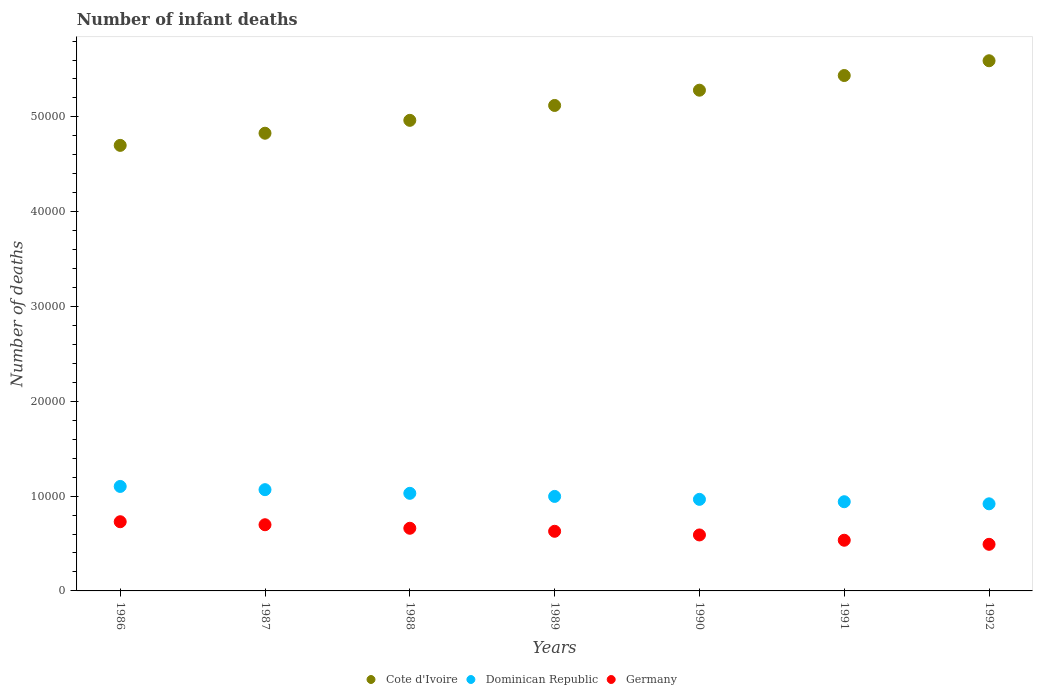Is the number of dotlines equal to the number of legend labels?
Your answer should be compact. Yes. What is the number of infant deaths in Germany in 1992?
Keep it short and to the point. 4916. Across all years, what is the maximum number of infant deaths in Germany?
Give a very brief answer. 7298. Across all years, what is the minimum number of infant deaths in Dominican Republic?
Your answer should be very brief. 9187. In which year was the number of infant deaths in Dominican Republic minimum?
Your answer should be compact. 1992. What is the total number of infant deaths in Germany in the graph?
Offer a terse response. 4.33e+04. What is the difference between the number of infant deaths in Germany in 1986 and that in 1990?
Your answer should be very brief. 1394. What is the difference between the number of infant deaths in Cote d'Ivoire in 1989 and the number of infant deaths in Dominican Republic in 1987?
Ensure brevity in your answer.  4.05e+04. What is the average number of infant deaths in Dominican Republic per year?
Make the answer very short. 1.00e+04. In the year 1986, what is the difference between the number of infant deaths in Germany and number of infant deaths in Cote d'Ivoire?
Your answer should be very brief. -3.97e+04. What is the ratio of the number of infant deaths in Germany in 1991 to that in 1992?
Ensure brevity in your answer.  1.09. Is the difference between the number of infant deaths in Germany in 1986 and 1992 greater than the difference between the number of infant deaths in Cote d'Ivoire in 1986 and 1992?
Your answer should be compact. Yes. What is the difference between the highest and the second highest number of infant deaths in Dominican Republic?
Ensure brevity in your answer.  341. What is the difference between the highest and the lowest number of infant deaths in Cote d'Ivoire?
Your response must be concise. 8926. Is the sum of the number of infant deaths in Cote d'Ivoire in 1986 and 1988 greater than the maximum number of infant deaths in Germany across all years?
Offer a very short reply. Yes. Is the number of infant deaths in Cote d'Ivoire strictly less than the number of infant deaths in Dominican Republic over the years?
Your response must be concise. No. How many years are there in the graph?
Keep it short and to the point. 7. Does the graph contain grids?
Make the answer very short. No. What is the title of the graph?
Your answer should be compact. Number of infant deaths. Does "Latin America(all income levels)" appear as one of the legend labels in the graph?
Your answer should be compact. No. What is the label or title of the X-axis?
Keep it short and to the point. Years. What is the label or title of the Y-axis?
Provide a short and direct response. Number of deaths. What is the Number of deaths of Cote d'Ivoire in 1986?
Offer a terse response. 4.70e+04. What is the Number of deaths in Dominican Republic in 1986?
Provide a short and direct response. 1.10e+04. What is the Number of deaths of Germany in 1986?
Make the answer very short. 7298. What is the Number of deaths of Cote d'Ivoire in 1987?
Offer a terse response. 4.83e+04. What is the Number of deaths of Dominican Republic in 1987?
Your response must be concise. 1.07e+04. What is the Number of deaths in Germany in 1987?
Your answer should be very brief. 6981. What is the Number of deaths in Cote d'Ivoire in 1988?
Ensure brevity in your answer.  4.96e+04. What is the Number of deaths of Dominican Republic in 1988?
Provide a succinct answer. 1.03e+04. What is the Number of deaths of Germany in 1988?
Your answer should be very brief. 6609. What is the Number of deaths of Cote d'Ivoire in 1989?
Provide a succinct answer. 5.12e+04. What is the Number of deaths in Dominican Republic in 1989?
Ensure brevity in your answer.  9968. What is the Number of deaths in Germany in 1989?
Provide a succinct answer. 6290. What is the Number of deaths of Cote d'Ivoire in 1990?
Keep it short and to the point. 5.28e+04. What is the Number of deaths of Dominican Republic in 1990?
Keep it short and to the point. 9658. What is the Number of deaths of Germany in 1990?
Give a very brief answer. 5904. What is the Number of deaths in Cote d'Ivoire in 1991?
Your answer should be compact. 5.44e+04. What is the Number of deaths in Dominican Republic in 1991?
Your answer should be compact. 9408. What is the Number of deaths of Germany in 1991?
Offer a terse response. 5346. What is the Number of deaths in Cote d'Ivoire in 1992?
Offer a terse response. 5.59e+04. What is the Number of deaths in Dominican Republic in 1992?
Your answer should be compact. 9187. What is the Number of deaths in Germany in 1992?
Ensure brevity in your answer.  4916. Across all years, what is the maximum Number of deaths in Cote d'Ivoire?
Keep it short and to the point. 5.59e+04. Across all years, what is the maximum Number of deaths of Dominican Republic?
Offer a terse response. 1.10e+04. Across all years, what is the maximum Number of deaths in Germany?
Your answer should be compact. 7298. Across all years, what is the minimum Number of deaths of Cote d'Ivoire?
Keep it short and to the point. 4.70e+04. Across all years, what is the minimum Number of deaths of Dominican Republic?
Keep it short and to the point. 9187. Across all years, what is the minimum Number of deaths of Germany?
Offer a very short reply. 4916. What is the total Number of deaths in Cote d'Ivoire in the graph?
Give a very brief answer. 3.59e+05. What is the total Number of deaths of Dominican Republic in the graph?
Your answer should be compact. 7.02e+04. What is the total Number of deaths in Germany in the graph?
Give a very brief answer. 4.33e+04. What is the difference between the Number of deaths in Cote d'Ivoire in 1986 and that in 1987?
Give a very brief answer. -1282. What is the difference between the Number of deaths in Dominican Republic in 1986 and that in 1987?
Offer a very short reply. 341. What is the difference between the Number of deaths in Germany in 1986 and that in 1987?
Provide a succinct answer. 317. What is the difference between the Number of deaths of Cote d'Ivoire in 1986 and that in 1988?
Offer a very short reply. -2641. What is the difference between the Number of deaths in Dominican Republic in 1986 and that in 1988?
Make the answer very short. 727. What is the difference between the Number of deaths of Germany in 1986 and that in 1988?
Your answer should be compact. 689. What is the difference between the Number of deaths of Cote d'Ivoire in 1986 and that in 1989?
Offer a very short reply. -4211. What is the difference between the Number of deaths of Dominican Republic in 1986 and that in 1989?
Make the answer very short. 1053. What is the difference between the Number of deaths in Germany in 1986 and that in 1989?
Keep it short and to the point. 1008. What is the difference between the Number of deaths in Cote d'Ivoire in 1986 and that in 1990?
Your response must be concise. -5820. What is the difference between the Number of deaths in Dominican Republic in 1986 and that in 1990?
Make the answer very short. 1363. What is the difference between the Number of deaths of Germany in 1986 and that in 1990?
Offer a very short reply. 1394. What is the difference between the Number of deaths of Cote d'Ivoire in 1986 and that in 1991?
Your answer should be very brief. -7368. What is the difference between the Number of deaths of Dominican Republic in 1986 and that in 1991?
Provide a short and direct response. 1613. What is the difference between the Number of deaths of Germany in 1986 and that in 1991?
Keep it short and to the point. 1952. What is the difference between the Number of deaths of Cote d'Ivoire in 1986 and that in 1992?
Provide a succinct answer. -8926. What is the difference between the Number of deaths of Dominican Republic in 1986 and that in 1992?
Provide a succinct answer. 1834. What is the difference between the Number of deaths of Germany in 1986 and that in 1992?
Make the answer very short. 2382. What is the difference between the Number of deaths in Cote d'Ivoire in 1987 and that in 1988?
Keep it short and to the point. -1359. What is the difference between the Number of deaths in Dominican Republic in 1987 and that in 1988?
Make the answer very short. 386. What is the difference between the Number of deaths of Germany in 1987 and that in 1988?
Offer a terse response. 372. What is the difference between the Number of deaths of Cote d'Ivoire in 1987 and that in 1989?
Make the answer very short. -2929. What is the difference between the Number of deaths of Dominican Republic in 1987 and that in 1989?
Make the answer very short. 712. What is the difference between the Number of deaths in Germany in 1987 and that in 1989?
Your answer should be very brief. 691. What is the difference between the Number of deaths in Cote d'Ivoire in 1987 and that in 1990?
Provide a succinct answer. -4538. What is the difference between the Number of deaths in Dominican Republic in 1987 and that in 1990?
Your answer should be compact. 1022. What is the difference between the Number of deaths of Germany in 1987 and that in 1990?
Offer a terse response. 1077. What is the difference between the Number of deaths of Cote d'Ivoire in 1987 and that in 1991?
Ensure brevity in your answer.  -6086. What is the difference between the Number of deaths of Dominican Republic in 1987 and that in 1991?
Give a very brief answer. 1272. What is the difference between the Number of deaths in Germany in 1987 and that in 1991?
Ensure brevity in your answer.  1635. What is the difference between the Number of deaths in Cote d'Ivoire in 1987 and that in 1992?
Provide a succinct answer. -7644. What is the difference between the Number of deaths of Dominican Republic in 1987 and that in 1992?
Provide a short and direct response. 1493. What is the difference between the Number of deaths of Germany in 1987 and that in 1992?
Your answer should be compact. 2065. What is the difference between the Number of deaths in Cote d'Ivoire in 1988 and that in 1989?
Offer a terse response. -1570. What is the difference between the Number of deaths of Dominican Republic in 1988 and that in 1989?
Provide a succinct answer. 326. What is the difference between the Number of deaths in Germany in 1988 and that in 1989?
Ensure brevity in your answer.  319. What is the difference between the Number of deaths in Cote d'Ivoire in 1988 and that in 1990?
Your answer should be very brief. -3179. What is the difference between the Number of deaths of Dominican Republic in 1988 and that in 1990?
Provide a short and direct response. 636. What is the difference between the Number of deaths in Germany in 1988 and that in 1990?
Keep it short and to the point. 705. What is the difference between the Number of deaths of Cote d'Ivoire in 1988 and that in 1991?
Your answer should be very brief. -4727. What is the difference between the Number of deaths of Dominican Republic in 1988 and that in 1991?
Make the answer very short. 886. What is the difference between the Number of deaths of Germany in 1988 and that in 1991?
Give a very brief answer. 1263. What is the difference between the Number of deaths of Cote d'Ivoire in 1988 and that in 1992?
Your answer should be compact. -6285. What is the difference between the Number of deaths of Dominican Republic in 1988 and that in 1992?
Offer a terse response. 1107. What is the difference between the Number of deaths of Germany in 1988 and that in 1992?
Your answer should be compact. 1693. What is the difference between the Number of deaths of Cote d'Ivoire in 1989 and that in 1990?
Your answer should be compact. -1609. What is the difference between the Number of deaths of Dominican Republic in 1989 and that in 1990?
Make the answer very short. 310. What is the difference between the Number of deaths in Germany in 1989 and that in 1990?
Offer a very short reply. 386. What is the difference between the Number of deaths of Cote d'Ivoire in 1989 and that in 1991?
Your answer should be very brief. -3157. What is the difference between the Number of deaths of Dominican Republic in 1989 and that in 1991?
Your answer should be compact. 560. What is the difference between the Number of deaths in Germany in 1989 and that in 1991?
Offer a terse response. 944. What is the difference between the Number of deaths of Cote d'Ivoire in 1989 and that in 1992?
Give a very brief answer. -4715. What is the difference between the Number of deaths in Dominican Republic in 1989 and that in 1992?
Ensure brevity in your answer.  781. What is the difference between the Number of deaths of Germany in 1989 and that in 1992?
Your response must be concise. 1374. What is the difference between the Number of deaths in Cote d'Ivoire in 1990 and that in 1991?
Ensure brevity in your answer.  -1548. What is the difference between the Number of deaths of Dominican Republic in 1990 and that in 1991?
Ensure brevity in your answer.  250. What is the difference between the Number of deaths in Germany in 1990 and that in 1991?
Your answer should be compact. 558. What is the difference between the Number of deaths in Cote d'Ivoire in 1990 and that in 1992?
Offer a very short reply. -3106. What is the difference between the Number of deaths of Dominican Republic in 1990 and that in 1992?
Offer a very short reply. 471. What is the difference between the Number of deaths in Germany in 1990 and that in 1992?
Your answer should be very brief. 988. What is the difference between the Number of deaths in Cote d'Ivoire in 1991 and that in 1992?
Offer a very short reply. -1558. What is the difference between the Number of deaths in Dominican Republic in 1991 and that in 1992?
Make the answer very short. 221. What is the difference between the Number of deaths of Germany in 1991 and that in 1992?
Offer a terse response. 430. What is the difference between the Number of deaths in Cote d'Ivoire in 1986 and the Number of deaths in Dominican Republic in 1987?
Provide a short and direct response. 3.63e+04. What is the difference between the Number of deaths of Cote d'Ivoire in 1986 and the Number of deaths of Germany in 1987?
Your answer should be very brief. 4.00e+04. What is the difference between the Number of deaths of Dominican Republic in 1986 and the Number of deaths of Germany in 1987?
Your answer should be very brief. 4040. What is the difference between the Number of deaths of Cote d'Ivoire in 1986 and the Number of deaths of Dominican Republic in 1988?
Keep it short and to the point. 3.67e+04. What is the difference between the Number of deaths of Cote d'Ivoire in 1986 and the Number of deaths of Germany in 1988?
Your answer should be compact. 4.04e+04. What is the difference between the Number of deaths of Dominican Republic in 1986 and the Number of deaths of Germany in 1988?
Give a very brief answer. 4412. What is the difference between the Number of deaths in Cote d'Ivoire in 1986 and the Number of deaths in Dominican Republic in 1989?
Your response must be concise. 3.70e+04. What is the difference between the Number of deaths of Cote d'Ivoire in 1986 and the Number of deaths of Germany in 1989?
Your answer should be compact. 4.07e+04. What is the difference between the Number of deaths of Dominican Republic in 1986 and the Number of deaths of Germany in 1989?
Provide a succinct answer. 4731. What is the difference between the Number of deaths of Cote d'Ivoire in 1986 and the Number of deaths of Dominican Republic in 1990?
Ensure brevity in your answer.  3.73e+04. What is the difference between the Number of deaths of Cote d'Ivoire in 1986 and the Number of deaths of Germany in 1990?
Your answer should be compact. 4.11e+04. What is the difference between the Number of deaths of Dominican Republic in 1986 and the Number of deaths of Germany in 1990?
Provide a succinct answer. 5117. What is the difference between the Number of deaths in Cote d'Ivoire in 1986 and the Number of deaths in Dominican Republic in 1991?
Give a very brief answer. 3.76e+04. What is the difference between the Number of deaths in Cote d'Ivoire in 1986 and the Number of deaths in Germany in 1991?
Your response must be concise. 4.16e+04. What is the difference between the Number of deaths in Dominican Republic in 1986 and the Number of deaths in Germany in 1991?
Your response must be concise. 5675. What is the difference between the Number of deaths in Cote d'Ivoire in 1986 and the Number of deaths in Dominican Republic in 1992?
Your answer should be very brief. 3.78e+04. What is the difference between the Number of deaths in Cote d'Ivoire in 1986 and the Number of deaths in Germany in 1992?
Offer a terse response. 4.21e+04. What is the difference between the Number of deaths of Dominican Republic in 1986 and the Number of deaths of Germany in 1992?
Offer a very short reply. 6105. What is the difference between the Number of deaths of Cote d'Ivoire in 1987 and the Number of deaths of Dominican Republic in 1988?
Keep it short and to the point. 3.80e+04. What is the difference between the Number of deaths of Cote d'Ivoire in 1987 and the Number of deaths of Germany in 1988?
Make the answer very short. 4.17e+04. What is the difference between the Number of deaths of Dominican Republic in 1987 and the Number of deaths of Germany in 1988?
Ensure brevity in your answer.  4071. What is the difference between the Number of deaths of Cote d'Ivoire in 1987 and the Number of deaths of Dominican Republic in 1989?
Ensure brevity in your answer.  3.83e+04. What is the difference between the Number of deaths in Cote d'Ivoire in 1987 and the Number of deaths in Germany in 1989?
Your answer should be very brief. 4.20e+04. What is the difference between the Number of deaths in Dominican Republic in 1987 and the Number of deaths in Germany in 1989?
Make the answer very short. 4390. What is the difference between the Number of deaths in Cote d'Ivoire in 1987 and the Number of deaths in Dominican Republic in 1990?
Your answer should be compact. 3.86e+04. What is the difference between the Number of deaths of Cote d'Ivoire in 1987 and the Number of deaths of Germany in 1990?
Make the answer very short. 4.24e+04. What is the difference between the Number of deaths in Dominican Republic in 1987 and the Number of deaths in Germany in 1990?
Provide a succinct answer. 4776. What is the difference between the Number of deaths of Cote d'Ivoire in 1987 and the Number of deaths of Dominican Republic in 1991?
Make the answer very short. 3.89e+04. What is the difference between the Number of deaths of Cote d'Ivoire in 1987 and the Number of deaths of Germany in 1991?
Offer a terse response. 4.29e+04. What is the difference between the Number of deaths in Dominican Republic in 1987 and the Number of deaths in Germany in 1991?
Offer a terse response. 5334. What is the difference between the Number of deaths in Cote d'Ivoire in 1987 and the Number of deaths in Dominican Republic in 1992?
Your answer should be compact. 3.91e+04. What is the difference between the Number of deaths in Cote d'Ivoire in 1987 and the Number of deaths in Germany in 1992?
Your response must be concise. 4.34e+04. What is the difference between the Number of deaths in Dominican Republic in 1987 and the Number of deaths in Germany in 1992?
Offer a terse response. 5764. What is the difference between the Number of deaths of Cote d'Ivoire in 1988 and the Number of deaths of Dominican Republic in 1989?
Your answer should be compact. 3.97e+04. What is the difference between the Number of deaths in Cote d'Ivoire in 1988 and the Number of deaths in Germany in 1989?
Offer a very short reply. 4.33e+04. What is the difference between the Number of deaths of Dominican Republic in 1988 and the Number of deaths of Germany in 1989?
Your response must be concise. 4004. What is the difference between the Number of deaths in Cote d'Ivoire in 1988 and the Number of deaths in Dominican Republic in 1990?
Give a very brief answer. 4.00e+04. What is the difference between the Number of deaths of Cote d'Ivoire in 1988 and the Number of deaths of Germany in 1990?
Ensure brevity in your answer.  4.37e+04. What is the difference between the Number of deaths in Dominican Republic in 1988 and the Number of deaths in Germany in 1990?
Offer a terse response. 4390. What is the difference between the Number of deaths of Cote d'Ivoire in 1988 and the Number of deaths of Dominican Republic in 1991?
Offer a very short reply. 4.02e+04. What is the difference between the Number of deaths of Cote d'Ivoire in 1988 and the Number of deaths of Germany in 1991?
Give a very brief answer. 4.43e+04. What is the difference between the Number of deaths of Dominican Republic in 1988 and the Number of deaths of Germany in 1991?
Provide a succinct answer. 4948. What is the difference between the Number of deaths of Cote d'Ivoire in 1988 and the Number of deaths of Dominican Republic in 1992?
Your answer should be compact. 4.04e+04. What is the difference between the Number of deaths in Cote d'Ivoire in 1988 and the Number of deaths in Germany in 1992?
Provide a short and direct response. 4.47e+04. What is the difference between the Number of deaths of Dominican Republic in 1988 and the Number of deaths of Germany in 1992?
Your response must be concise. 5378. What is the difference between the Number of deaths of Cote d'Ivoire in 1989 and the Number of deaths of Dominican Republic in 1990?
Ensure brevity in your answer.  4.15e+04. What is the difference between the Number of deaths of Cote d'Ivoire in 1989 and the Number of deaths of Germany in 1990?
Your answer should be compact. 4.53e+04. What is the difference between the Number of deaths in Dominican Republic in 1989 and the Number of deaths in Germany in 1990?
Offer a terse response. 4064. What is the difference between the Number of deaths in Cote d'Ivoire in 1989 and the Number of deaths in Dominican Republic in 1991?
Offer a terse response. 4.18e+04. What is the difference between the Number of deaths of Cote d'Ivoire in 1989 and the Number of deaths of Germany in 1991?
Provide a short and direct response. 4.59e+04. What is the difference between the Number of deaths in Dominican Republic in 1989 and the Number of deaths in Germany in 1991?
Your answer should be very brief. 4622. What is the difference between the Number of deaths of Cote d'Ivoire in 1989 and the Number of deaths of Dominican Republic in 1992?
Offer a very short reply. 4.20e+04. What is the difference between the Number of deaths of Cote d'Ivoire in 1989 and the Number of deaths of Germany in 1992?
Keep it short and to the point. 4.63e+04. What is the difference between the Number of deaths of Dominican Republic in 1989 and the Number of deaths of Germany in 1992?
Offer a terse response. 5052. What is the difference between the Number of deaths in Cote d'Ivoire in 1990 and the Number of deaths in Dominican Republic in 1991?
Offer a very short reply. 4.34e+04. What is the difference between the Number of deaths in Cote d'Ivoire in 1990 and the Number of deaths in Germany in 1991?
Keep it short and to the point. 4.75e+04. What is the difference between the Number of deaths of Dominican Republic in 1990 and the Number of deaths of Germany in 1991?
Provide a succinct answer. 4312. What is the difference between the Number of deaths in Cote d'Ivoire in 1990 and the Number of deaths in Dominican Republic in 1992?
Your response must be concise. 4.36e+04. What is the difference between the Number of deaths in Cote d'Ivoire in 1990 and the Number of deaths in Germany in 1992?
Provide a succinct answer. 4.79e+04. What is the difference between the Number of deaths in Dominican Republic in 1990 and the Number of deaths in Germany in 1992?
Your response must be concise. 4742. What is the difference between the Number of deaths of Cote d'Ivoire in 1991 and the Number of deaths of Dominican Republic in 1992?
Offer a very short reply. 4.52e+04. What is the difference between the Number of deaths in Cote d'Ivoire in 1991 and the Number of deaths in Germany in 1992?
Keep it short and to the point. 4.94e+04. What is the difference between the Number of deaths in Dominican Republic in 1991 and the Number of deaths in Germany in 1992?
Make the answer very short. 4492. What is the average Number of deaths of Cote d'Ivoire per year?
Give a very brief answer. 5.13e+04. What is the average Number of deaths in Dominican Republic per year?
Your answer should be compact. 1.00e+04. What is the average Number of deaths of Germany per year?
Give a very brief answer. 6192. In the year 1986, what is the difference between the Number of deaths of Cote d'Ivoire and Number of deaths of Dominican Republic?
Provide a short and direct response. 3.60e+04. In the year 1986, what is the difference between the Number of deaths in Cote d'Ivoire and Number of deaths in Germany?
Your response must be concise. 3.97e+04. In the year 1986, what is the difference between the Number of deaths in Dominican Republic and Number of deaths in Germany?
Provide a short and direct response. 3723. In the year 1987, what is the difference between the Number of deaths in Cote d'Ivoire and Number of deaths in Dominican Republic?
Ensure brevity in your answer.  3.76e+04. In the year 1987, what is the difference between the Number of deaths of Cote d'Ivoire and Number of deaths of Germany?
Your response must be concise. 4.13e+04. In the year 1987, what is the difference between the Number of deaths in Dominican Republic and Number of deaths in Germany?
Your answer should be compact. 3699. In the year 1988, what is the difference between the Number of deaths in Cote d'Ivoire and Number of deaths in Dominican Republic?
Ensure brevity in your answer.  3.93e+04. In the year 1988, what is the difference between the Number of deaths of Cote d'Ivoire and Number of deaths of Germany?
Keep it short and to the point. 4.30e+04. In the year 1988, what is the difference between the Number of deaths of Dominican Republic and Number of deaths of Germany?
Offer a terse response. 3685. In the year 1989, what is the difference between the Number of deaths in Cote d'Ivoire and Number of deaths in Dominican Republic?
Make the answer very short. 4.12e+04. In the year 1989, what is the difference between the Number of deaths in Cote d'Ivoire and Number of deaths in Germany?
Your answer should be very brief. 4.49e+04. In the year 1989, what is the difference between the Number of deaths of Dominican Republic and Number of deaths of Germany?
Make the answer very short. 3678. In the year 1990, what is the difference between the Number of deaths of Cote d'Ivoire and Number of deaths of Dominican Republic?
Ensure brevity in your answer.  4.32e+04. In the year 1990, what is the difference between the Number of deaths of Cote d'Ivoire and Number of deaths of Germany?
Your answer should be compact. 4.69e+04. In the year 1990, what is the difference between the Number of deaths of Dominican Republic and Number of deaths of Germany?
Give a very brief answer. 3754. In the year 1991, what is the difference between the Number of deaths of Cote d'Ivoire and Number of deaths of Dominican Republic?
Keep it short and to the point. 4.50e+04. In the year 1991, what is the difference between the Number of deaths in Cote d'Ivoire and Number of deaths in Germany?
Offer a very short reply. 4.90e+04. In the year 1991, what is the difference between the Number of deaths of Dominican Republic and Number of deaths of Germany?
Give a very brief answer. 4062. In the year 1992, what is the difference between the Number of deaths in Cote d'Ivoire and Number of deaths in Dominican Republic?
Your answer should be very brief. 4.67e+04. In the year 1992, what is the difference between the Number of deaths of Cote d'Ivoire and Number of deaths of Germany?
Make the answer very short. 5.10e+04. In the year 1992, what is the difference between the Number of deaths in Dominican Republic and Number of deaths in Germany?
Provide a short and direct response. 4271. What is the ratio of the Number of deaths in Cote d'Ivoire in 1986 to that in 1987?
Keep it short and to the point. 0.97. What is the ratio of the Number of deaths in Dominican Republic in 1986 to that in 1987?
Offer a terse response. 1.03. What is the ratio of the Number of deaths in Germany in 1986 to that in 1987?
Give a very brief answer. 1.05. What is the ratio of the Number of deaths in Cote d'Ivoire in 1986 to that in 1988?
Give a very brief answer. 0.95. What is the ratio of the Number of deaths of Dominican Republic in 1986 to that in 1988?
Keep it short and to the point. 1.07. What is the ratio of the Number of deaths in Germany in 1986 to that in 1988?
Offer a terse response. 1.1. What is the ratio of the Number of deaths in Cote d'Ivoire in 1986 to that in 1989?
Your response must be concise. 0.92. What is the ratio of the Number of deaths in Dominican Republic in 1986 to that in 1989?
Offer a terse response. 1.11. What is the ratio of the Number of deaths of Germany in 1986 to that in 1989?
Your answer should be compact. 1.16. What is the ratio of the Number of deaths of Cote d'Ivoire in 1986 to that in 1990?
Make the answer very short. 0.89. What is the ratio of the Number of deaths in Dominican Republic in 1986 to that in 1990?
Give a very brief answer. 1.14. What is the ratio of the Number of deaths of Germany in 1986 to that in 1990?
Offer a very short reply. 1.24. What is the ratio of the Number of deaths of Cote d'Ivoire in 1986 to that in 1991?
Offer a terse response. 0.86. What is the ratio of the Number of deaths of Dominican Republic in 1986 to that in 1991?
Make the answer very short. 1.17. What is the ratio of the Number of deaths of Germany in 1986 to that in 1991?
Your response must be concise. 1.37. What is the ratio of the Number of deaths of Cote d'Ivoire in 1986 to that in 1992?
Your answer should be very brief. 0.84. What is the ratio of the Number of deaths in Dominican Republic in 1986 to that in 1992?
Ensure brevity in your answer.  1.2. What is the ratio of the Number of deaths of Germany in 1986 to that in 1992?
Your answer should be very brief. 1.48. What is the ratio of the Number of deaths of Cote d'Ivoire in 1987 to that in 1988?
Your answer should be compact. 0.97. What is the ratio of the Number of deaths of Dominican Republic in 1987 to that in 1988?
Offer a terse response. 1.04. What is the ratio of the Number of deaths in Germany in 1987 to that in 1988?
Your answer should be compact. 1.06. What is the ratio of the Number of deaths in Cote d'Ivoire in 1987 to that in 1989?
Keep it short and to the point. 0.94. What is the ratio of the Number of deaths of Dominican Republic in 1987 to that in 1989?
Keep it short and to the point. 1.07. What is the ratio of the Number of deaths of Germany in 1987 to that in 1989?
Make the answer very short. 1.11. What is the ratio of the Number of deaths in Cote d'Ivoire in 1987 to that in 1990?
Offer a very short reply. 0.91. What is the ratio of the Number of deaths of Dominican Republic in 1987 to that in 1990?
Offer a terse response. 1.11. What is the ratio of the Number of deaths of Germany in 1987 to that in 1990?
Keep it short and to the point. 1.18. What is the ratio of the Number of deaths in Cote d'Ivoire in 1987 to that in 1991?
Provide a succinct answer. 0.89. What is the ratio of the Number of deaths of Dominican Republic in 1987 to that in 1991?
Provide a succinct answer. 1.14. What is the ratio of the Number of deaths in Germany in 1987 to that in 1991?
Offer a very short reply. 1.31. What is the ratio of the Number of deaths of Cote d'Ivoire in 1987 to that in 1992?
Make the answer very short. 0.86. What is the ratio of the Number of deaths of Dominican Republic in 1987 to that in 1992?
Offer a very short reply. 1.16. What is the ratio of the Number of deaths in Germany in 1987 to that in 1992?
Ensure brevity in your answer.  1.42. What is the ratio of the Number of deaths in Cote d'Ivoire in 1988 to that in 1989?
Your answer should be very brief. 0.97. What is the ratio of the Number of deaths in Dominican Republic in 1988 to that in 1989?
Offer a terse response. 1.03. What is the ratio of the Number of deaths of Germany in 1988 to that in 1989?
Your answer should be compact. 1.05. What is the ratio of the Number of deaths of Cote d'Ivoire in 1988 to that in 1990?
Provide a succinct answer. 0.94. What is the ratio of the Number of deaths in Dominican Republic in 1988 to that in 1990?
Provide a short and direct response. 1.07. What is the ratio of the Number of deaths in Germany in 1988 to that in 1990?
Give a very brief answer. 1.12. What is the ratio of the Number of deaths of Dominican Republic in 1988 to that in 1991?
Provide a short and direct response. 1.09. What is the ratio of the Number of deaths of Germany in 1988 to that in 1991?
Ensure brevity in your answer.  1.24. What is the ratio of the Number of deaths of Cote d'Ivoire in 1988 to that in 1992?
Make the answer very short. 0.89. What is the ratio of the Number of deaths in Dominican Republic in 1988 to that in 1992?
Your response must be concise. 1.12. What is the ratio of the Number of deaths in Germany in 1988 to that in 1992?
Ensure brevity in your answer.  1.34. What is the ratio of the Number of deaths in Cote d'Ivoire in 1989 to that in 1990?
Provide a short and direct response. 0.97. What is the ratio of the Number of deaths of Dominican Republic in 1989 to that in 1990?
Offer a terse response. 1.03. What is the ratio of the Number of deaths in Germany in 1989 to that in 1990?
Your response must be concise. 1.07. What is the ratio of the Number of deaths in Cote d'Ivoire in 1989 to that in 1991?
Offer a very short reply. 0.94. What is the ratio of the Number of deaths in Dominican Republic in 1989 to that in 1991?
Your answer should be very brief. 1.06. What is the ratio of the Number of deaths in Germany in 1989 to that in 1991?
Provide a succinct answer. 1.18. What is the ratio of the Number of deaths in Cote d'Ivoire in 1989 to that in 1992?
Make the answer very short. 0.92. What is the ratio of the Number of deaths in Dominican Republic in 1989 to that in 1992?
Offer a terse response. 1.08. What is the ratio of the Number of deaths of Germany in 1989 to that in 1992?
Give a very brief answer. 1.28. What is the ratio of the Number of deaths in Cote d'Ivoire in 1990 to that in 1991?
Make the answer very short. 0.97. What is the ratio of the Number of deaths in Dominican Republic in 1990 to that in 1991?
Offer a very short reply. 1.03. What is the ratio of the Number of deaths of Germany in 1990 to that in 1991?
Keep it short and to the point. 1.1. What is the ratio of the Number of deaths of Cote d'Ivoire in 1990 to that in 1992?
Provide a short and direct response. 0.94. What is the ratio of the Number of deaths in Dominican Republic in 1990 to that in 1992?
Your response must be concise. 1.05. What is the ratio of the Number of deaths in Germany in 1990 to that in 1992?
Keep it short and to the point. 1.2. What is the ratio of the Number of deaths in Cote d'Ivoire in 1991 to that in 1992?
Keep it short and to the point. 0.97. What is the ratio of the Number of deaths of Dominican Republic in 1991 to that in 1992?
Make the answer very short. 1.02. What is the ratio of the Number of deaths of Germany in 1991 to that in 1992?
Provide a short and direct response. 1.09. What is the difference between the highest and the second highest Number of deaths in Cote d'Ivoire?
Provide a short and direct response. 1558. What is the difference between the highest and the second highest Number of deaths of Dominican Republic?
Your response must be concise. 341. What is the difference between the highest and the second highest Number of deaths of Germany?
Make the answer very short. 317. What is the difference between the highest and the lowest Number of deaths in Cote d'Ivoire?
Your response must be concise. 8926. What is the difference between the highest and the lowest Number of deaths of Dominican Republic?
Provide a succinct answer. 1834. What is the difference between the highest and the lowest Number of deaths of Germany?
Offer a terse response. 2382. 